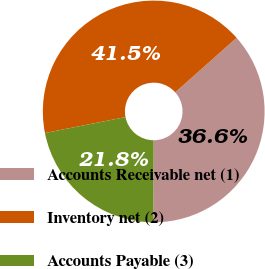Convert chart. <chart><loc_0><loc_0><loc_500><loc_500><pie_chart><fcel>Accounts Receivable net (1)<fcel>Inventory net (2)<fcel>Accounts Payable (3)<nl><fcel>36.62%<fcel>41.55%<fcel>21.83%<nl></chart> 